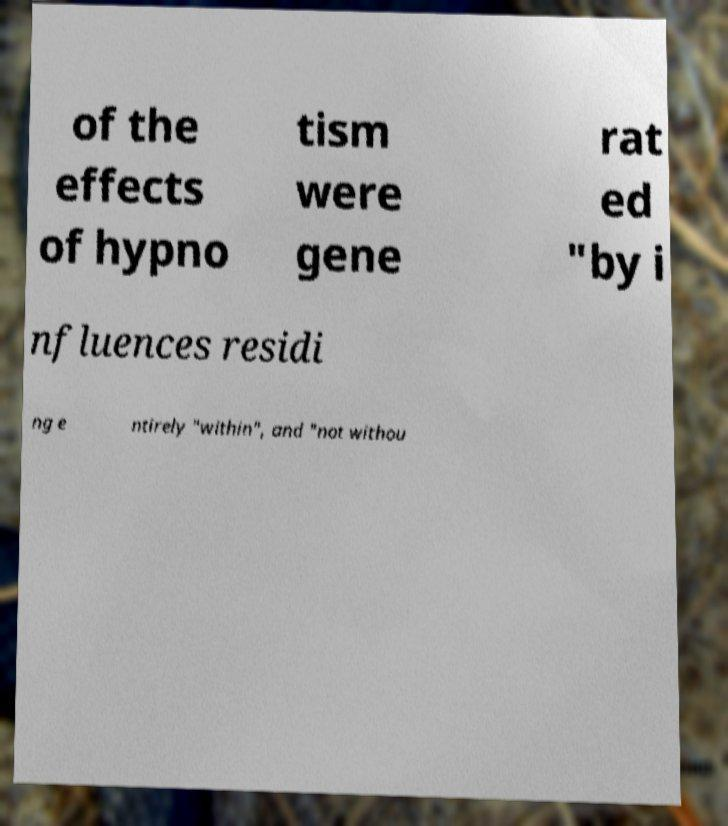I need the written content from this picture converted into text. Can you do that? of the effects of hypno tism were gene rat ed "by i nfluences residi ng e ntirely "within", and "not withou 